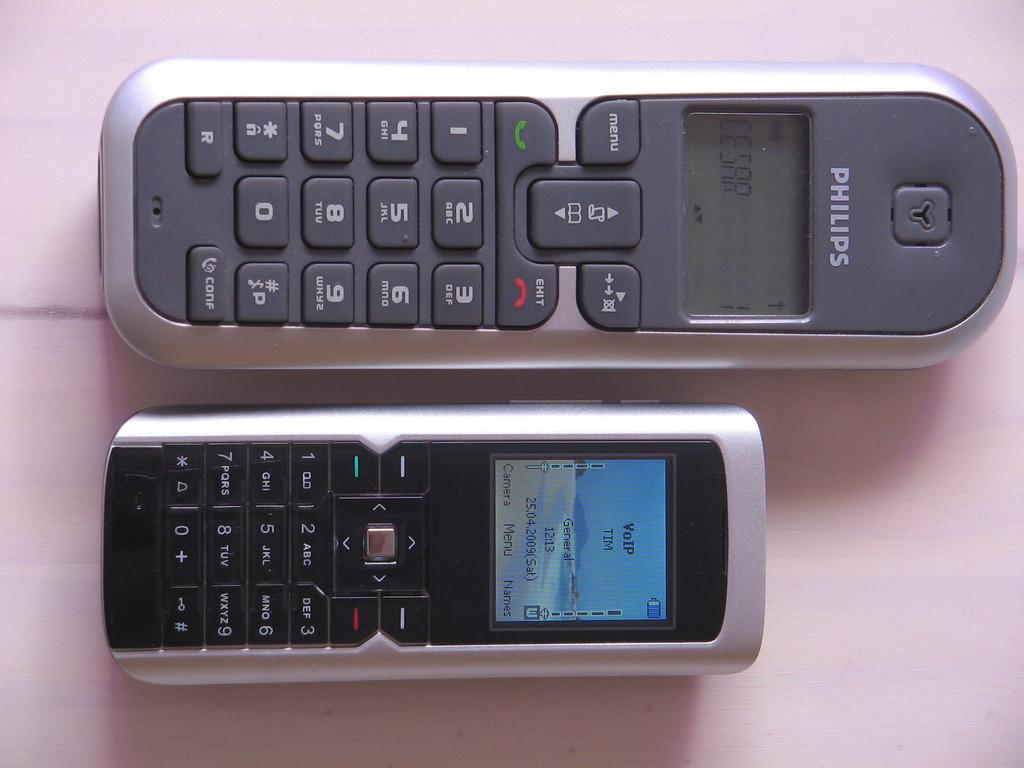Provide a one-sentence caption for the provided image. A picture of two phones one of which is a Phillips phone. 